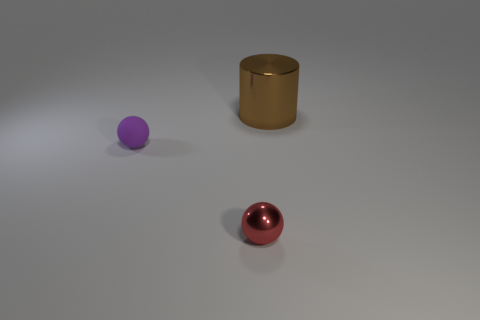Add 2 tiny red balls. How many objects exist? 5 Subtract 1 cylinders. How many cylinders are left? 0 Subtract all green balls. Subtract all yellow cubes. How many balls are left? 2 Subtract all gray cylinders. How many cyan spheres are left? 0 Subtract all shiny things. Subtract all tiny brown matte cylinders. How many objects are left? 1 Add 2 tiny purple things. How many tiny purple things are left? 3 Add 1 brown metal objects. How many brown metal objects exist? 2 Subtract all red balls. How many balls are left? 1 Subtract 0 purple cylinders. How many objects are left? 3 Subtract all spheres. How many objects are left? 1 